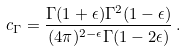Convert formula to latex. <formula><loc_0><loc_0><loc_500><loc_500>c _ { \Gamma } = \frac { \Gamma ( 1 + \epsilon ) \Gamma ^ { 2 } ( 1 - \epsilon ) } { ( 4 \pi ) ^ { 2 - \epsilon } \Gamma ( 1 - 2 \epsilon ) } \, .</formula> 